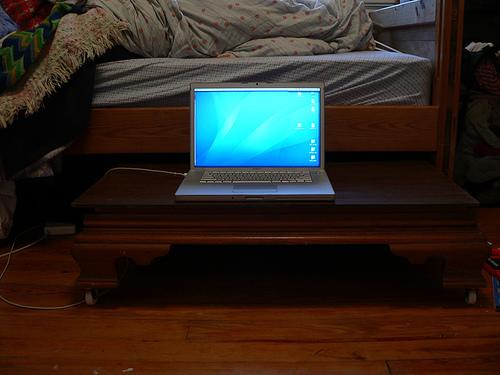What is sitting on the table next to the bed?
Concise answer only. Laptop. Where was this photo taken?
Be succinct. Bedroom. Is the bed made up?
Write a very short answer. No. Who is sleeping in the bed?
Quick response, please. Man. How many mirrors are there?
Short answer required. 0. 